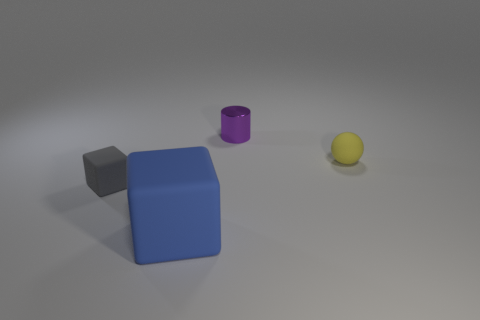There is a small matte object on the right side of the tiny cylinder; is its shape the same as the tiny shiny thing?
Your response must be concise. No. Are there more matte blocks that are on the left side of the gray rubber thing than tiny cyan balls?
Make the answer very short. No. How many rubber cubes are on the left side of the blue block and in front of the small gray rubber thing?
Offer a very short reply. 0. What color is the thing that is in front of the tiny rubber object that is on the left side of the small yellow rubber thing?
Keep it short and to the point. Blue. How many other things are the same color as the large rubber object?
Your answer should be very brief. 0. Do the large matte block and the small rubber thing in front of the small yellow matte sphere have the same color?
Ensure brevity in your answer.  No. Is the number of large purple rubber spheres less than the number of gray matte blocks?
Your response must be concise. Yes. Are there more tiny yellow objects that are behind the tiny yellow matte sphere than cylinders on the left side of the small gray thing?
Your answer should be compact. No. Is the purple cylinder made of the same material as the gray object?
Give a very brief answer. No. What number of cylinders are behind the thing behind the small yellow rubber ball?
Your answer should be compact. 0. 